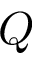<formula> <loc_0><loc_0><loc_500><loc_500>Q</formula> 